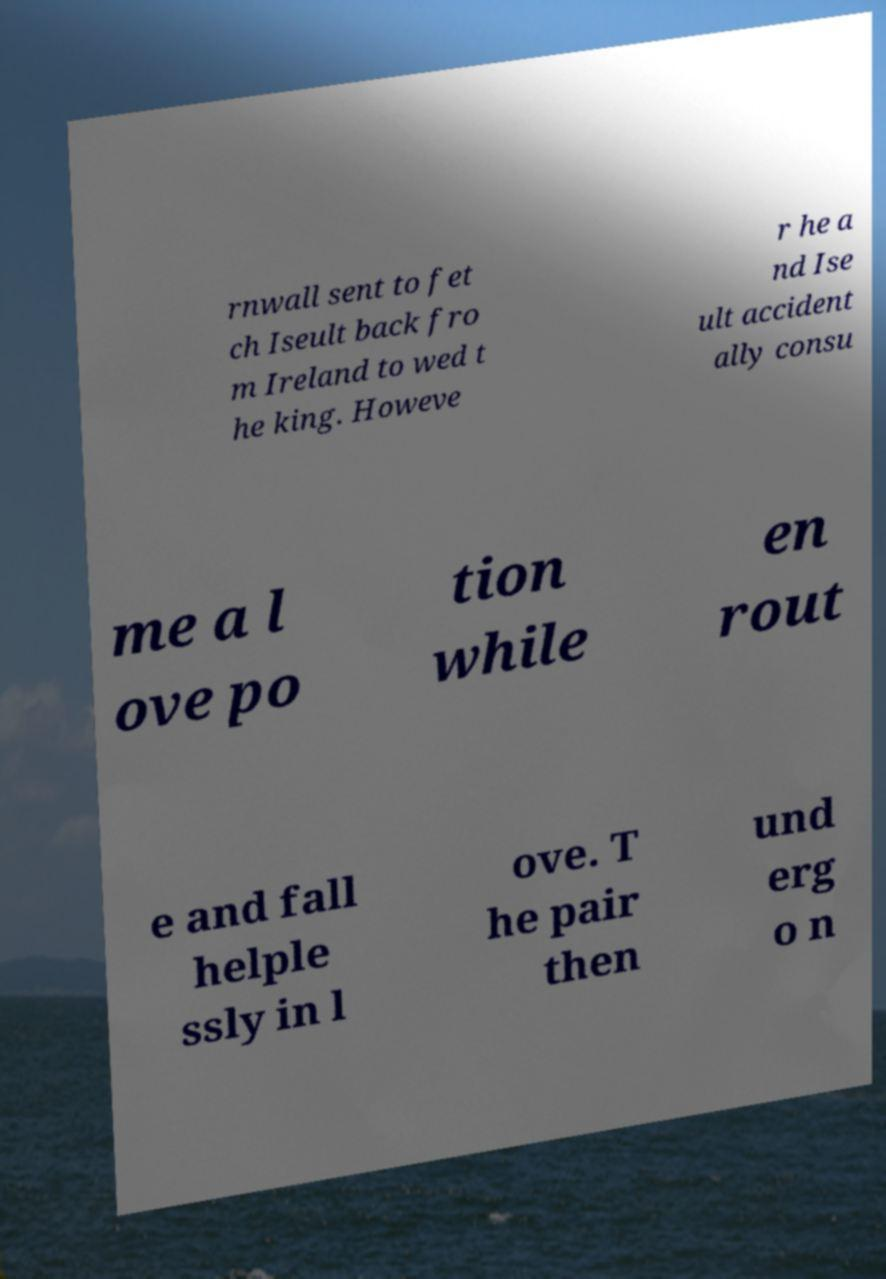What messages or text are displayed in this image? I need them in a readable, typed format. rnwall sent to fet ch Iseult back fro m Ireland to wed t he king. Howeve r he a nd Ise ult accident ally consu me a l ove po tion while en rout e and fall helple ssly in l ove. T he pair then und erg o n 